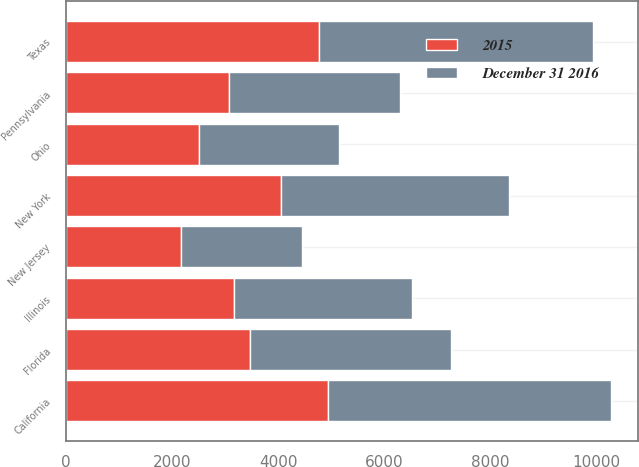<chart> <loc_0><loc_0><loc_500><loc_500><stacked_bar_chart><ecel><fcel>California<fcel>Texas<fcel>New York<fcel>Florida<fcel>Illinois<fcel>Pennsylvania<fcel>Ohio<fcel>New Jersey<nl><fcel>December 31 2016<fcel>5317<fcel>5156<fcel>4295<fcel>3793<fcel>3350<fcel>3233<fcel>2646<fcel>2282<nl><fcel>2015<fcel>4947<fcel>4781<fcel>4061<fcel>3463<fcel>3170<fcel>3071<fcel>2511<fcel>2163<nl></chart> 